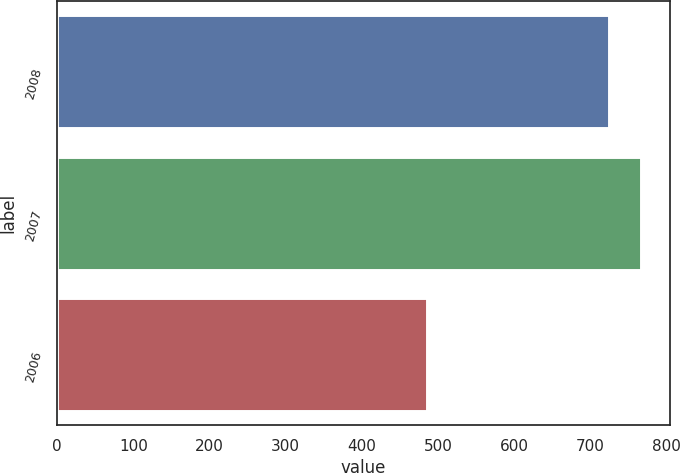Convert chart. <chart><loc_0><loc_0><loc_500><loc_500><bar_chart><fcel>2008<fcel>2007<fcel>2006<nl><fcel>723.4<fcel>766<fcel>485.5<nl></chart> 